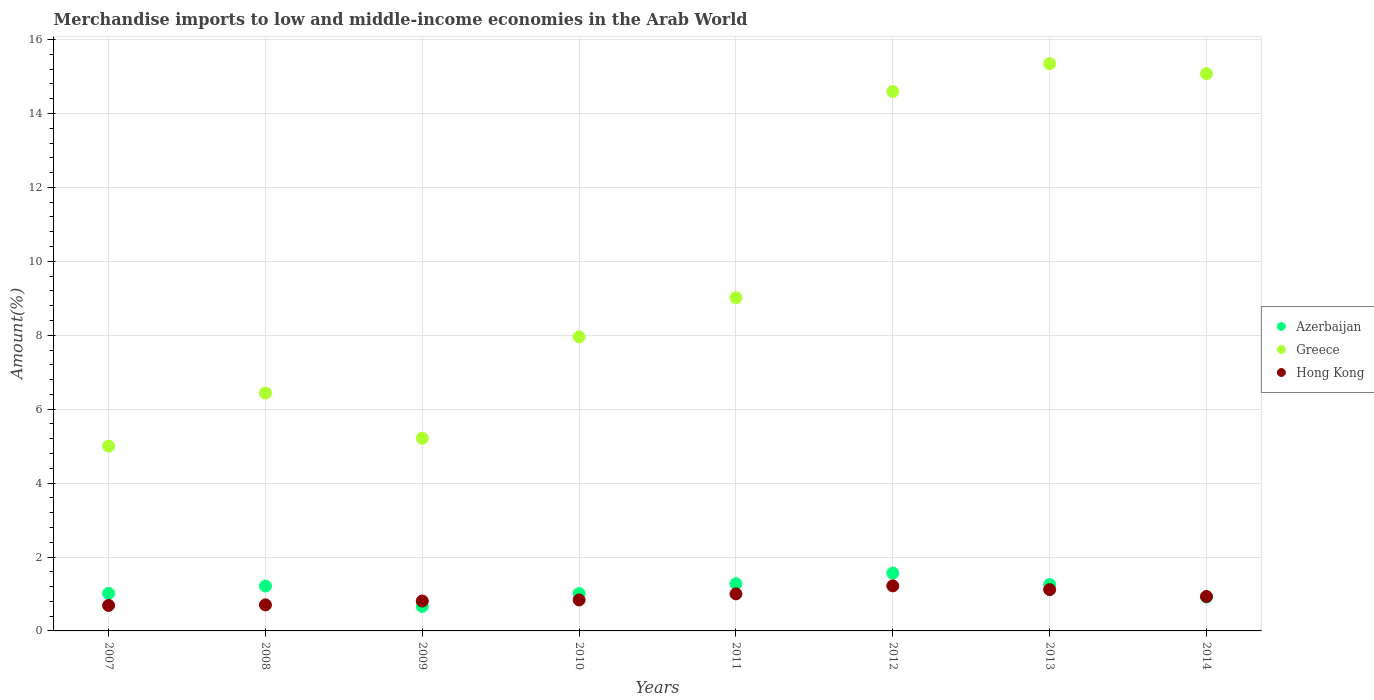How many different coloured dotlines are there?
Your answer should be very brief. 3. Is the number of dotlines equal to the number of legend labels?
Make the answer very short. Yes. What is the percentage of amount earned from merchandise imports in Hong Kong in 2009?
Your response must be concise. 0.81. Across all years, what is the maximum percentage of amount earned from merchandise imports in Greece?
Provide a succinct answer. 15.35. Across all years, what is the minimum percentage of amount earned from merchandise imports in Hong Kong?
Your response must be concise. 0.69. In which year was the percentage of amount earned from merchandise imports in Hong Kong maximum?
Offer a very short reply. 2012. In which year was the percentage of amount earned from merchandise imports in Greece minimum?
Your answer should be compact. 2007. What is the total percentage of amount earned from merchandise imports in Greece in the graph?
Keep it short and to the point. 78.64. What is the difference between the percentage of amount earned from merchandise imports in Greece in 2011 and that in 2013?
Provide a short and direct response. -6.33. What is the difference between the percentage of amount earned from merchandise imports in Hong Kong in 2011 and the percentage of amount earned from merchandise imports in Azerbaijan in 2014?
Give a very brief answer. 0.09. What is the average percentage of amount earned from merchandise imports in Azerbaijan per year?
Your response must be concise. 1.11. In the year 2008, what is the difference between the percentage of amount earned from merchandise imports in Greece and percentage of amount earned from merchandise imports in Azerbaijan?
Provide a short and direct response. 5.22. What is the ratio of the percentage of amount earned from merchandise imports in Hong Kong in 2007 to that in 2011?
Your answer should be very brief. 0.69. Is the difference between the percentage of amount earned from merchandise imports in Greece in 2009 and 2014 greater than the difference between the percentage of amount earned from merchandise imports in Azerbaijan in 2009 and 2014?
Your response must be concise. No. What is the difference between the highest and the second highest percentage of amount earned from merchandise imports in Greece?
Offer a very short reply. 0.27. What is the difference between the highest and the lowest percentage of amount earned from merchandise imports in Azerbaijan?
Your answer should be compact. 0.9. In how many years, is the percentage of amount earned from merchandise imports in Hong Kong greater than the average percentage of amount earned from merchandise imports in Hong Kong taken over all years?
Your answer should be very brief. 4. Is the sum of the percentage of amount earned from merchandise imports in Greece in 2010 and 2011 greater than the maximum percentage of amount earned from merchandise imports in Azerbaijan across all years?
Your response must be concise. Yes. Does the percentage of amount earned from merchandise imports in Hong Kong monotonically increase over the years?
Offer a terse response. No. How many dotlines are there?
Offer a terse response. 3. How many years are there in the graph?
Provide a short and direct response. 8. What is the difference between two consecutive major ticks on the Y-axis?
Provide a short and direct response. 2. Are the values on the major ticks of Y-axis written in scientific E-notation?
Offer a terse response. No. Does the graph contain grids?
Offer a very short reply. Yes. How many legend labels are there?
Offer a terse response. 3. How are the legend labels stacked?
Make the answer very short. Vertical. What is the title of the graph?
Ensure brevity in your answer.  Merchandise imports to low and middle-income economies in the Arab World. Does "Kuwait" appear as one of the legend labels in the graph?
Your answer should be very brief. No. What is the label or title of the Y-axis?
Your answer should be very brief. Amount(%). What is the Amount(%) in Azerbaijan in 2007?
Provide a short and direct response. 1.02. What is the Amount(%) in Greece in 2007?
Your answer should be compact. 5. What is the Amount(%) of Hong Kong in 2007?
Keep it short and to the point. 0.69. What is the Amount(%) of Azerbaijan in 2008?
Provide a succinct answer. 1.21. What is the Amount(%) in Greece in 2008?
Your response must be concise. 6.44. What is the Amount(%) of Hong Kong in 2008?
Ensure brevity in your answer.  0.7. What is the Amount(%) in Azerbaijan in 2009?
Make the answer very short. 0.66. What is the Amount(%) of Greece in 2009?
Your answer should be very brief. 5.21. What is the Amount(%) in Hong Kong in 2009?
Your response must be concise. 0.81. What is the Amount(%) in Azerbaijan in 2010?
Offer a terse response. 1.01. What is the Amount(%) in Greece in 2010?
Offer a very short reply. 7.96. What is the Amount(%) of Hong Kong in 2010?
Provide a succinct answer. 0.84. What is the Amount(%) in Azerbaijan in 2011?
Give a very brief answer. 1.28. What is the Amount(%) of Greece in 2011?
Offer a terse response. 9.02. What is the Amount(%) of Hong Kong in 2011?
Make the answer very short. 1. What is the Amount(%) of Azerbaijan in 2012?
Offer a terse response. 1.57. What is the Amount(%) of Greece in 2012?
Your answer should be compact. 14.59. What is the Amount(%) of Hong Kong in 2012?
Give a very brief answer. 1.22. What is the Amount(%) in Azerbaijan in 2013?
Ensure brevity in your answer.  1.25. What is the Amount(%) of Greece in 2013?
Provide a short and direct response. 15.35. What is the Amount(%) of Hong Kong in 2013?
Your response must be concise. 1.12. What is the Amount(%) in Azerbaijan in 2014?
Your answer should be compact. 0.91. What is the Amount(%) of Greece in 2014?
Keep it short and to the point. 15.08. What is the Amount(%) in Hong Kong in 2014?
Provide a short and direct response. 0.93. Across all years, what is the maximum Amount(%) in Azerbaijan?
Your answer should be very brief. 1.57. Across all years, what is the maximum Amount(%) in Greece?
Your answer should be compact. 15.35. Across all years, what is the maximum Amount(%) of Hong Kong?
Ensure brevity in your answer.  1.22. Across all years, what is the minimum Amount(%) in Azerbaijan?
Ensure brevity in your answer.  0.66. Across all years, what is the minimum Amount(%) in Greece?
Offer a terse response. 5. Across all years, what is the minimum Amount(%) of Hong Kong?
Ensure brevity in your answer.  0.69. What is the total Amount(%) of Azerbaijan in the graph?
Keep it short and to the point. 8.92. What is the total Amount(%) of Greece in the graph?
Make the answer very short. 78.64. What is the total Amount(%) in Hong Kong in the graph?
Give a very brief answer. 7.31. What is the difference between the Amount(%) of Azerbaijan in 2007 and that in 2008?
Your response must be concise. -0.2. What is the difference between the Amount(%) in Greece in 2007 and that in 2008?
Keep it short and to the point. -1.43. What is the difference between the Amount(%) in Hong Kong in 2007 and that in 2008?
Ensure brevity in your answer.  -0.01. What is the difference between the Amount(%) in Azerbaijan in 2007 and that in 2009?
Make the answer very short. 0.35. What is the difference between the Amount(%) of Greece in 2007 and that in 2009?
Your answer should be very brief. -0.21. What is the difference between the Amount(%) in Hong Kong in 2007 and that in 2009?
Keep it short and to the point. -0.12. What is the difference between the Amount(%) of Azerbaijan in 2007 and that in 2010?
Your answer should be very brief. 0. What is the difference between the Amount(%) of Greece in 2007 and that in 2010?
Provide a short and direct response. -2.95. What is the difference between the Amount(%) in Hong Kong in 2007 and that in 2010?
Provide a succinct answer. -0.15. What is the difference between the Amount(%) in Azerbaijan in 2007 and that in 2011?
Make the answer very short. -0.26. What is the difference between the Amount(%) of Greece in 2007 and that in 2011?
Your answer should be compact. -4.02. What is the difference between the Amount(%) in Hong Kong in 2007 and that in 2011?
Offer a terse response. -0.31. What is the difference between the Amount(%) in Azerbaijan in 2007 and that in 2012?
Your answer should be compact. -0.55. What is the difference between the Amount(%) in Greece in 2007 and that in 2012?
Your response must be concise. -9.59. What is the difference between the Amount(%) in Hong Kong in 2007 and that in 2012?
Provide a succinct answer. -0.53. What is the difference between the Amount(%) of Azerbaijan in 2007 and that in 2013?
Provide a short and direct response. -0.24. What is the difference between the Amount(%) of Greece in 2007 and that in 2013?
Provide a succinct answer. -10.35. What is the difference between the Amount(%) in Hong Kong in 2007 and that in 2013?
Offer a very short reply. -0.43. What is the difference between the Amount(%) of Azerbaijan in 2007 and that in 2014?
Offer a terse response. 0.1. What is the difference between the Amount(%) in Greece in 2007 and that in 2014?
Your answer should be very brief. -10.08. What is the difference between the Amount(%) of Hong Kong in 2007 and that in 2014?
Ensure brevity in your answer.  -0.24. What is the difference between the Amount(%) in Azerbaijan in 2008 and that in 2009?
Offer a very short reply. 0.55. What is the difference between the Amount(%) in Greece in 2008 and that in 2009?
Your answer should be compact. 1.22. What is the difference between the Amount(%) in Hong Kong in 2008 and that in 2009?
Make the answer very short. -0.1. What is the difference between the Amount(%) in Azerbaijan in 2008 and that in 2010?
Your answer should be very brief. 0.2. What is the difference between the Amount(%) of Greece in 2008 and that in 2010?
Your answer should be compact. -1.52. What is the difference between the Amount(%) in Hong Kong in 2008 and that in 2010?
Provide a short and direct response. -0.13. What is the difference between the Amount(%) in Azerbaijan in 2008 and that in 2011?
Your response must be concise. -0.06. What is the difference between the Amount(%) in Greece in 2008 and that in 2011?
Provide a short and direct response. -2.58. What is the difference between the Amount(%) in Hong Kong in 2008 and that in 2011?
Provide a short and direct response. -0.3. What is the difference between the Amount(%) of Azerbaijan in 2008 and that in 2012?
Your answer should be very brief. -0.35. What is the difference between the Amount(%) in Greece in 2008 and that in 2012?
Your answer should be compact. -8.16. What is the difference between the Amount(%) of Hong Kong in 2008 and that in 2012?
Provide a short and direct response. -0.52. What is the difference between the Amount(%) of Azerbaijan in 2008 and that in 2013?
Your answer should be very brief. -0.04. What is the difference between the Amount(%) of Greece in 2008 and that in 2013?
Your answer should be compact. -8.91. What is the difference between the Amount(%) in Hong Kong in 2008 and that in 2013?
Offer a very short reply. -0.41. What is the difference between the Amount(%) of Azerbaijan in 2008 and that in 2014?
Give a very brief answer. 0.3. What is the difference between the Amount(%) of Greece in 2008 and that in 2014?
Your response must be concise. -8.64. What is the difference between the Amount(%) of Hong Kong in 2008 and that in 2014?
Provide a succinct answer. -0.23. What is the difference between the Amount(%) in Azerbaijan in 2009 and that in 2010?
Make the answer very short. -0.35. What is the difference between the Amount(%) of Greece in 2009 and that in 2010?
Provide a short and direct response. -2.74. What is the difference between the Amount(%) of Hong Kong in 2009 and that in 2010?
Give a very brief answer. -0.03. What is the difference between the Amount(%) of Azerbaijan in 2009 and that in 2011?
Make the answer very short. -0.61. What is the difference between the Amount(%) in Greece in 2009 and that in 2011?
Provide a short and direct response. -3.8. What is the difference between the Amount(%) of Hong Kong in 2009 and that in 2011?
Your answer should be very brief. -0.19. What is the difference between the Amount(%) of Azerbaijan in 2009 and that in 2012?
Provide a short and direct response. -0.9. What is the difference between the Amount(%) of Greece in 2009 and that in 2012?
Make the answer very short. -9.38. What is the difference between the Amount(%) in Hong Kong in 2009 and that in 2012?
Keep it short and to the point. -0.41. What is the difference between the Amount(%) in Azerbaijan in 2009 and that in 2013?
Offer a very short reply. -0.59. What is the difference between the Amount(%) of Greece in 2009 and that in 2013?
Offer a terse response. -10.13. What is the difference between the Amount(%) of Hong Kong in 2009 and that in 2013?
Offer a terse response. -0.31. What is the difference between the Amount(%) in Azerbaijan in 2009 and that in 2014?
Offer a terse response. -0.25. What is the difference between the Amount(%) of Greece in 2009 and that in 2014?
Your response must be concise. -9.86. What is the difference between the Amount(%) of Hong Kong in 2009 and that in 2014?
Keep it short and to the point. -0.12. What is the difference between the Amount(%) of Azerbaijan in 2010 and that in 2011?
Your answer should be compact. -0.26. What is the difference between the Amount(%) of Greece in 2010 and that in 2011?
Make the answer very short. -1.06. What is the difference between the Amount(%) in Hong Kong in 2010 and that in 2011?
Keep it short and to the point. -0.17. What is the difference between the Amount(%) in Azerbaijan in 2010 and that in 2012?
Provide a short and direct response. -0.55. What is the difference between the Amount(%) in Greece in 2010 and that in 2012?
Your response must be concise. -6.64. What is the difference between the Amount(%) in Hong Kong in 2010 and that in 2012?
Keep it short and to the point. -0.38. What is the difference between the Amount(%) in Azerbaijan in 2010 and that in 2013?
Make the answer very short. -0.24. What is the difference between the Amount(%) in Greece in 2010 and that in 2013?
Ensure brevity in your answer.  -7.39. What is the difference between the Amount(%) of Hong Kong in 2010 and that in 2013?
Offer a very short reply. -0.28. What is the difference between the Amount(%) in Azerbaijan in 2010 and that in 2014?
Provide a short and direct response. 0.1. What is the difference between the Amount(%) of Greece in 2010 and that in 2014?
Make the answer very short. -7.12. What is the difference between the Amount(%) of Hong Kong in 2010 and that in 2014?
Ensure brevity in your answer.  -0.09. What is the difference between the Amount(%) in Azerbaijan in 2011 and that in 2012?
Offer a terse response. -0.29. What is the difference between the Amount(%) of Greece in 2011 and that in 2012?
Offer a terse response. -5.58. What is the difference between the Amount(%) of Hong Kong in 2011 and that in 2012?
Provide a short and direct response. -0.22. What is the difference between the Amount(%) of Azerbaijan in 2011 and that in 2013?
Make the answer very short. 0.02. What is the difference between the Amount(%) of Greece in 2011 and that in 2013?
Offer a terse response. -6.33. What is the difference between the Amount(%) of Hong Kong in 2011 and that in 2013?
Provide a succinct answer. -0.12. What is the difference between the Amount(%) of Azerbaijan in 2011 and that in 2014?
Your response must be concise. 0.36. What is the difference between the Amount(%) of Greece in 2011 and that in 2014?
Provide a short and direct response. -6.06. What is the difference between the Amount(%) in Hong Kong in 2011 and that in 2014?
Offer a terse response. 0.07. What is the difference between the Amount(%) of Azerbaijan in 2012 and that in 2013?
Keep it short and to the point. 0.31. What is the difference between the Amount(%) of Greece in 2012 and that in 2013?
Offer a very short reply. -0.75. What is the difference between the Amount(%) of Hong Kong in 2012 and that in 2013?
Give a very brief answer. 0.1. What is the difference between the Amount(%) in Azerbaijan in 2012 and that in 2014?
Make the answer very short. 0.65. What is the difference between the Amount(%) in Greece in 2012 and that in 2014?
Your answer should be very brief. -0.48. What is the difference between the Amount(%) in Hong Kong in 2012 and that in 2014?
Give a very brief answer. 0.29. What is the difference between the Amount(%) in Azerbaijan in 2013 and that in 2014?
Your response must be concise. 0.34. What is the difference between the Amount(%) in Greece in 2013 and that in 2014?
Offer a very short reply. 0.27. What is the difference between the Amount(%) in Hong Kong in 2013 and that in 2014?
Offer a terse response. 0.19. What is the difference between the Amount(%) of Azerbaijan in 2007 and the Amount(%) of Greece in 2008?
Offer a terse response. -5.42. What is the difference between the Amount(%) in Azerbaijan in 2007 and the Amount(%) in Hong Kong in 2008?
Keep it short and to the point. 0.31. What is the difference between the Amount(%) of Greece in 2007 and the Amount(%) of Hong Kong in 2008?
Offer a terse response. 4.3. What is the difference between the Amount(%) of Azerbaijan in 2007 and the Amount(%) of Greece in 2009?
Ensure brevity in your answer.  -4.2. What is the difference between the Amount(%) of Azerbaijan in 2007 and the Amount(%) of Hong Kong in 2009?
Provide a short and direct response. 0.21. What is the difference between the Amount(%) of Greece in 2007 and the Amount(%) of Hong Kong in 2009?
Make the answer very short. 4.19. What is the difference between the Amount(%) in Azerbaijan in 2007 and the Amount(%) in Greece in 2010?
Keep it short and to the point. -6.94. What is the difference between the Amount(%) in Azerbaijan in 2007 and the Amount(%) in Hong Kong in 2010?
Ensure brevity in your answer.  0.18. What is the difference between the Amount(%) in Greece in 2007 and the Amount(%) in Hong Kong in 2010?
Keep it short and to the point. 4.16. What is the difference between the Amount(%) in Azerbaijan in 2007 and the Amount(%) in Greece in 2011?
Provide a short and direct response. -8. What is the difference between the Amount(%) in Azerbaijan in 2007 and the Amount(%) in Hong Kong in 2011?
Provide a succinct answer. 0.01. What is the difference between the Amount(%) of Greece in 2007 and the Amount(%) of Hong Kong in 2011?
Ensure brevity in your answer.  4. What is the difference between the Amount(%) in Azerbaijan in 2007 and the Amount(%) in Greece in 2012?
Offer a very short reply. -13.58. What is the difference between the Amount(%) in Azerbaijan in 2007 and the Amount(%) in Hong Kong in 2012?
Offer a very short reply. -0.2. What is the difference between the Amount(%) in Greece in 2007 and the Amount(%) in Hong Kong in 2012?
Your answer should be very brief. 3.78. What is the difference between the Amount(%) of Azerbaijan in 2007 and the Amount(%) of Greece in 2013?
Offer a very short reply. -14.33. What is the difference between the Amount(%) in Azerbaijan in 2007 and the Amount(%) in Hong Kong in 2013?
Your response must be concise. -0.1. What is the difference between the Amount(%) in Greece in 2007 and the Amount(%) in Hong Kong in 2013?
Your answer should be compact. 3.88. What is the difference between the Amount(%) of Azerbaijan in 2007 and the Amount(%) of Greece in 2014?
Ensure brevity in your answer.  -14.06. What is the difference between the Amount(%) in Azerbaijan in 2007 and the Amount(%) in Hong Kong in 2014?
Give a very brief answer. 0.08. What is the difference between the Amount(%) in Greece in 2007 and the Amount(%) in Hong Kong in 2014?
Your answer should be compact. 4.07. What is the difference between the Amount(%) of Azerbaijan in 2008 and the Amount(%) of Greece in 2009?
Provide a short and direct response. -4. What is the difference between the Amount(%) in Azerbaijan in 2008 and the Amount(%) in Hong Kong in 2009?
Provide a short and direct response. 0.41. What is the difference between the Amount(%) of Greece in 2008 and the Amount(%) of Hong Kong in 2009?
Make the answer very short. 5.63. What is the difference between the Amount(%) of Azerbaijan in 2008 and the Amount(%) of Greece in 2010?
Provide a succinct answer. -6.74. What is the difference between the Amount(%) of Azerbaijan in 2008 and the Amount(%) of Hong Kong in 2010?
Provide a short and direct response. 0.38. What is the difference between the Amount(%) in Greece in 2008 and the Amount(%) in Hong Kong in 2010?
Offer a very short reply. 5.6. What is the difference between the Amount(%) in Azerbaijan in 2008 and the Amount(%) in Greece in 2011?
Give a very brief answer. -7.8. What is the difference between the Amount(%) of Azerbaijan in 2008 and the Amount(%) of Hong Kong in 2011?
Provide a succinct answer. 0.21. What is the difference between the Amount(%) in Greece in 2008 and the Amount(%) in Hong Kong in 2011?
Offer a terse response. 5.43. What is the difference between the Amount(%) of Azerbaijan in 2008 and the Amount(%) of Greece in 2012?
Your response must be concise. -13.38. What is the difference between the Amount(%) of Azerbaijan in 2008 and the Amount(%) of Hong Kong in 2012?
Make the answer very short. -0.01. What is the difference between the Amount(%) of Greece in 2008 and the Amount(%) of Hong Kong in 2012?
Make the answer very short. 5.22. What is the difference between the Amount(%) of Azerbaijan in 2008 and the Amount(%) of Greece in 2013?
Your response must be concise. -14.13. What is the difference between the Amount(%) in Azerbaijan in 2008 and the Amount(%) in Hong Kong in 2013?
Ensure brevity in your answer.  0.1. What is the difference between the Amount(%) in Greece in 2008 and the Amount(%) in Hong Kong in 2013?
Your response must be concise. 5.32. What is the difference between the Amount(%) of Azerbaijan in 2008 and the Amount(%) of Greece in 2014?
Give a very brief answer. -13.86. What is the difference between the Amount(%) in Azerbaijan in 2008 and the Amount(%) in Hong Kong in 2014?
Give a very brief answer. 0.28. What is the difference between the Amount(%) of Greece in 2008 and the Amount(%) of Hong Kong in 2014?
Ensure brevity in your answer.  5.5. What is the difference between the Amount(%) of Azerbaijan in 2009 and the Amount(%) of Greece in 2010?
Offer a terse response. -7.29. What is the difference between the Amount(%) of Azerbaijan in 2009 and the Amount(%) of Hong Kong in 2010?
Give a very brief answer. -0.17. What is the difference between the Amount(%) of Greece in 2009 and the Amount(%) of Hong Kong in 2010?
Offer a terse response. 4.38. What is the difference between the Amount(%) of Azerbaijan in 2009 and the Amount(%) of Greece in 2011?
Your answer should be compact. -8.35. What is the difference between the Amount(%) in Azerbaijan in 2009 and the Amount(%) in Hong Kong in 2011?
Provide a short and direct response. -0.34. What is the difference between the Amount(%) in Greece in 2009 and the Amount(%) in Hong Kong in 2011?
Provide a succinct answer. 4.21. What is the difference between the Amount(%) in Azerbaijan in 2009 and the Amount(%) in Greece in 2012?
Provide a short and direct response. -13.93. What is the difference between the Amount(%) of Azerbaijan in 2009 and the Amount(%) of Hong Kong in 2012?
Your answer should be very brief. -0.56. What is the difference between the Amount(%) in Greece in 2009 and the Amount(%) in Hong Kong in 2012?
Provide a short and direct response. 4. What is the difference between the Amount(%) in Azerbaijan in 2009 and the Amount(%) in Greece in 2013?
Your response must be concise. -14.68. What is the difference between the Amount(%) of Azerbaijan in 2009 and the Amount(%) of Hong Kong in 2013?
Your answer should be very brief. -0.46. What is the difference between the Amount(%) in Greece in 2009 and the Amount(%) in Hong Kong in 2013?
Provide a short and direct response. 4.1. What is the difference between the Amount(%) of Azerbaijan in 2009 and the Amount(%) of Greece in 2014?
Keep it short and to the point. -14.41. What is the difference between the Amount(%) in Azerbaijan in 2009 and the Amount(%) in Hong Kong in 2014?
Your answer should be compact. -0.27. What is the difference between the Amount(%) of Greece in 2009 and the Amount(%) of Hong Kong in 2014?
Offer a terse response. 4.28. What is the difference between the Amount(%) in Azerbaijan in 2010 and the Amount(%) in Greece in 2011?
Provide a succinct answer. -8.01. What is the difference between the Amount(%) in Azerbaijan in 2010 and the Amount(%) in Hong Kong in 2011?
Keep it short and to the point. 0.01. What is the difference between the Amount(%) of Greece in 2010 and the Amount(%) of Hong Kong in 2011?
Ensure brevity in your answer.  6.95. What is the difference between the Amount(%) in Azerbaijan in 2010 and the Amount(%) in Greece in 2012?
Your answer should be very brief. -13.58. What is the difference between the Amount(%) of Azerbaijan in 2010 and the Amount(%) of Hong Kong in 2012?
Provide a succinct answer. -0.21. What is the difference between the Amount(%) of Greece in 2010 and the Amount(%) of Hong Kong in 2012?
Ensure brevity in your answer.  6.74. What is the difference between the Amount(%) of Azerbaijan in 2010 and the Amount(%) of Greece in 2013?
Provide a succinct answer. -14.34. What is the difference between the Amount(%) in Azerbaijan in 2010 and the Amount(%) in Hong Kong in 2013?
Offer a terse response. -0.11. What is the difference between the Amount(%) of Greece in 2010 and the Amount(%) of Hong Kong in 2013?
Make the answer very short. 6.84. What is the difference between the Amount(%) in Azerbaijan in 2010 and the Amount(%) in Greece in 2014?
Provide a short and direct response. -14.06. What is the difference between the Amount(%) in Azerbaijan in 2010 and the Amount(%) in Hong Kong in 2014?
Keep it short and to the point. 0.08. What is the difference between the Amount(%) in Greece in 2010 and the Amount(%) in Hong Kong in 2014?
Offer a terse response. 7.02. What is the difference between the Amount(%) in Azerbaijan in 2011 and the Amount(%) in Greece in 2012?
Your answer should be very brief. -13.32. What is the difference between the Amount(%) in Azerbaijan in 2011 and the Amount(%) in Hong Kong in 2012?
Provide a succinct answer. 0.06. What is the difference between the Amount(%) in Greece in 2011 and the Amount(%) in Hong Kong in 2012?
Give a very brief answer. 7.8. What is the difference between the Amount(%) of Azerbaijan in 2011 and the Amount(%) of Greece in 2013?
Your answer should be very brief. -14.07. What is the difference between the Amount(%) in Azerbaijan in 2011 and the Amount(%) in Hong Kong in 2013?
Your answer should be compact. 0.16. What is the difference between the Amount(%) in Greece in 2011 and the Amount(%) in Hong Kong in 2013?
Provide a succinct answer. 7.9. What is the difference between the Amount(%) in Azerbaijan in 2011 and the Amount(%) in Greece in 2014?
Your response must be concise. -13.8. What is the difference between the Amount(%) in Azerbaijan in 2011 and the Amount(%) in Hong Kong in 2014?
Offer a very short reply. 0.34. What is the difference between the Amount(%) in Greece in 2011 and the Amount(%) in Hong Kong in 2014?
Give a very brief answer. 8.09. What is the difference between the Amount(%) in Azerbaijan in 2012 and the Amount(%) in Greece in 2013?
Give a very brief answer. -13.78. What is the difference between the Amount(%) of Azerbaijan in 2012 and the Amount(%) of Hong Kong in 2013?
Keep it short and to the point. 0.45. What is the difference between the Amount(%) of Greece in 2012 and the Amount(%) of Hong Kong in 2013?
Your response must be concise. 13.48. What is the difference between the Amount(%) of Azerbaijan in 2012 and the Amount(%) of Greece in 2014?
Provide a short and direct response. -13.51. What is the difference between the Amount(%) of Azerbaijan in 2012 and the Amount(%) of Hong Kong in 2014?
Your answer should be compact. 0.63. What is the difference between the Amount(%) in Greece in 2012 and the Amount(%) in Hong Kong in 2014?
Make the answer very short. 13.66. What is the difference between the Amount(%) in Azerbaijan in 2013 and the Amount(%) in Greece in 2014?
Offer a very short reply. -13.82. What is the difference between the Amount(%) in Azerbaijan in 2013 and the Amount(%) in Hong Kong in 2014?
Make the answer very short. 0.32. What is the difference between the Amount(%) of Greece in 2013 and the Amount(%) of Hong Kong in 2014?
Keep it short and to the point. 14.41. What is the average Amount(%) in Azerbaijan per year?
Keep it short and to the point. 1.11. What is the average Amount(%) of Greece per year?
Keep it short and to the point. 9.83. What is the average Amount(%) in Hong Kong per year?
Provide a succinct answer. 0.91. In the year 2007, what is the difference between the Amount(%) of Azerbaijan and Amount(%) of Greece?
Give a very brief answer. -3.98. In the year 2007, what is the difference between the Amount(%) in Azerbaijan and Amount(%) in Hong Kong?
Offer a terse response. 0.33. In the year 2007, what is the difference between the Amount(%) of Greece and Amount(%) of Hong Kong?
Provide a succinct answer. 4.31. In the year 2008, what is the difference between the Amount(%) in Azerbaijan and Amount(%) in Greece?
Make the answer very short. -5.22. In the year 2008, what is the difference between the Amount(%) of Azerbaijan and Amount(%) of Hong Kong?
Your answer should be compact. 0.51. In the year 2008, what is the difference between the Amount(%) in Greece and Amount(%) in Hong Kong?
Provide a succinct answer. 5.73. In the year 2009, what is the difference between the Amount(%) of Azerbaijan and Amount(%) of Greece?
Ensure brevity in your answer.  -4.55. In the year 2009, what is the difference between the Amount(%) in Azerbaijan and Amount(%) in Hong Kong?
Offer a terse response. -0.15. In the year 2009, what is the difference between the Amount(%) of Greece and Amount(%) of Hong Kong?
Your answer should be very brief. 4.41. In the year 2010, what is the difference between the Amount(%) of Azerbaijan and Amount(%) of Greece?
Make the answer very short. -6.94. In the year 2010, what is the difference between the Amount(%) in Azerbaijan and Amount(%) in Hong Kong?
Give a very brief answer. 0.17. In the year 2010, what is the difference between the Amount(%) in Greece and Amount(%) in Hong Kong?
Your response must be concise. 7.12. In the year 2011, what is the difference between the Amount(%) in Azerbaijan and Amount(%) in Greece?
Your answer should be compact. -7.74. In the year 2011, what is the difference between the Amount(%) in Azerbaijan and Amount(%) in Hong Kong?
Your answer should be very brief. 0.27. In the year 2011, what is the difference between the Amount(%) in Greece and Amount(%) in Hong Kong?
Make the answer very short. 8.01. In the year 2012, what is the difference between the Amount(%) of Azerbaijan and Amount(%) of Greece?
Provide a short and direct response. -13.03. In the year 2012, what is the difference between the Amount(%) of Azerbaijan and Amount(%) of Hong Kong?
Your answer should be compact. 0.35. In the year 2012, what is the difference between the Amount(%) of Greece and Amount(%) of Hong Kong?
Offer a very short reply. 13.37. In the year 2013, what is the difference between the Amount(%) of Azerbaijan and Amount(%) of Greece?
Ensure brevity in your answer.  -14.09. In the year 2013, what is the difference between the Amount(%) in Azerbaijan and Amount(%) in Hong Kong?
Provide a short and direct response. 0.14. In the year 2013, what is the difference between the Amount(%) in Greece and Amount(%) in Hong Kong?
Your response must be concise. 14.23. In the year 2014, what is the difference between the Amount(%) in Azerbaijan and Amount(%) in Greece?
Make the answer very short. -14.16. In the year 2014, what is the difference between the Amount(%) in Azerbaijan and Amount(%) in Hong Kong?
Provide a short and direct response. -0.02. In the year 2014, what is the difference between the Amount(%) of Greece and Amount(%) of Hong Kong?
Make the answer very short. 14.14. What is the ratio of the Amount(%) in Azerbaijan in 2007 to that in 2008?
Your answer should be very brief. 0.84. What is the ratio of the Amount(%) in Greece in 2007 to that in 2008?
Keep it short and to the point. 0.78. What is the ratio of the Amount(%) in Hong Kong in 2007 to that in 2008?
Provide a succinct answer. 0.98. What is the ratio of the Amount(%) of Azerbaijan in 2007 to that in 2009?
Ensure brevity in your answer.  1.53. What is the ratio of the Amount(%) in Greece in 2007 to that in 2009?
Your answer should be very brief. 0.96. What is the ratio of the Amount(%) of Hong Kong in 2007 to that in 2009?
Offer a terse response. 0.85. What is the ratio of the Amount(%) in Greece in 2007 to that in 2010?
Keep it short and to the point. 0.63. What is the ratio of the Amount(%) of Hong Kong in 2007 to that in 2010?
Give a very brief answer. 0.82. What is the ratio of the Amount(%) of Azerbaijan in 2007 to that in 2011?
Ensure brevity in your answer.  0.8. What is the ratio of the Amount(%) in Greece in 2007 to that in 2011?
Keep it short and to the point. 0.55. What is the ratio of the Amount(%) of Hong Kong in 2007 to that in 2011?
Ensure brevity in your answer.  0.69. What is the ratio of the Amount(%) of Azerbaijan in 2007 to that in 2012?
Make the answer very short. 0.65. What is the ratio of the Amount(%) of Greece in 2007 to that in 2012?
Offer a very short reply. 0.34. What is the ratio of the Amount(%) in Hong Kong in 2007 to that in 2012?
Keep it short and to the point. 0.57. What is the ratio of the Amount(%) of Azerbaijan in 2007 to that in 2013?
Give a very brief answer. 0.81. What is the ratio of the Amount(%) of Greece in 2007 to that in 2013?
Offer a terse response. 0.33. What is the ratio of the Amount(%) in Hong Kong in 2007 to that in 2013?
Your response must be concise. 0.62. What is the ratio of the Amount(%) in Azerbaijan in 2007 to that in 2014?
Give a very brief answer. 1.11. What is the ratio of the Amount(%) of Greece in 2007 to that in 2014?
Provide a succinct answer. 0.33. What is the ratio of the Amount(%) in Hong Kong in 2007 to that in 2014?
Make the answer very short. 0.74. What is the ratio of the Amount(%) of Azerbaijan in 2008 to that in 2009?
Keep it short and to the point. 1.83. What is the ratio of the Amount(%) of Greece in 2008 to that in 2009?
Your answer should be compact. 1.23. What is the ratio of the Amount(%) in Hong Kong in 2008 to that in 2009?
Offer a terse response. 0.87. What is the ratio of the Amount(%) of Azerbaijan in 2008 to that in 2010?
Your answer should be compact. 1.2. What is the ratio of the Amount(%) in Greece in 2008 to that in 2010?
Keep it short and to the point. 0.81. What is the ratio of the Amount(%) of Hong Kong in 2008 to that in 2010?
Ensure brevity in your answer.  0.84. What is the ratio of the Amount(%) in Azerbaijan in 2008 to that in 2011?
Give a very brief answer. 0.95. What is the ratio of the Amount(%) of Greece in 2008 to that in 2011?
Provide a succinct answer. 0.71. What is the ratio of the Amount(%) of Hong Kong in 2008 to that in 2011?
Make the answer very short. 0.7. What is the ratio of the Amount(%) of Azerbaijan in 2008 to that in 2012?
Make the answer very short. 0.78. What is the ratio of the Amount(%) of Greece in 2008 to that in 2012?
Provide a succinct answer. 0.44. What is the ratio of the Amount(%) of Hong Kong in 2008 to that in 2012?
Your answer should be compact. 0.58. What is the ratio of the Amount(%) in Azerbaijan in 2008 to that in 2013?
Your answer should be very brief. 0.97. What is the ratio of the Amount(%) in Greece in 2008 to that in 2013?
Provide a succinct answer. 0.42. What is the ratio of the Amount(%) of Hong Kong in 2008 to that in 2013?
Your answer should be compact. 0.63. What is the ratio of the Amount(%) of Azerbaijan in 2008 to that in 2014?
Your answer should be compact. 1.33. What is the ratio of the Amount(%) of Greece in 2008 to that in 2014?
Keep it short and to the point. 0.43. What is the ratio of the Amount(%) of Hong Kong in 2008 to that in 2014?
Your answer should be very brief. 0.76. What is the ratio of the Amount(%) of Azerbaijan in 2009 to that in 2010?
Keep it short and to the point. 0.66. What is the ratio of the Amount(%) in Greece in 2009 to that in 2010?
Your answer should be very brief. 0.66. What is the ratio of the Amount(%) of Hong Kong in 2009 to that in 2010?
Keep it short and to the point. 0.97. What is the ratio of the Amount(%) of Azerbaijan in 2009 to that in 2011?
Keep it short and to the point. 0.52. What is the ratio of the Amount(%) in Greece in 2009 to that in 2011?
Your answer should be very brief. 0.58. What is the ratio of the Amount(%) in Hong Kong in 2009 to that in 2011?
Your response must be concise. 0.81. What is the ratio of the Amount(%) in Azerbaijan in 2009 to that in 2012?
Give a very brief answer. 0.42. What is the ratio of the Amount(%) in Greece in 2009 to that in 2012?
Provide a short and direct response. 0.36. What is the ratio of the Amount(%) of Hong Kong in 2009 to that in 2012?
Provide a short and direct response. 0.66. What is the ratio of the Amount(%) of Azerbaijan in 2009 to that in 2013?
Ensure brevity in your answer.  0.53. What is the ratio of the Amount(%) in Greece in 2009 to that in 2013?
Provide a short and direct response. 0.34. What is the ratio of the Amount(%) in Hong Kong in 2009 to that in 2013?
Offer a terse response. 0.72. What is the ratio of the Amount(%) in Azerbaijan in 2009 to that in 2014?
Your response must be concise. 0.72. What is the ratio of the Amount(%) in Greece in 2009 to that in 2014?
Keep it short and to the point. 0.35. What is the ratio of the Amount(%) in Hong Kong in 2009 to that in 2014?
Your answer should be very brief. 0.87. What is the ratio of the Amount(%) in Azerbaijan in 2010 to that in 2011?
Your answer should be very brief. 0.79. What is the ratio of the Amount(%) in Greece in 2010 to that in 2011?
Provide a short and direct response. 0.88. What is the ratio of the Amount(%) of Hong Kong in 2010 to that in 2011?
Provide a short and direct response. 0.84. What is the ratio of the Amount(%) in Azerbaijan in 2010 to that in 2012?
Give a very brief answer. 0.65. What is the ratio of the Amount(%) in Greece in 2010 to that in 2012?
Provide a short and direct response. 0.55. What is the ratio of the Amount(%) in Hong Kong in 2010 to that in 2012?
Make the answer very short. 0.69. What is the ratio of the Amount(%) in Azerbaijan in 2010 to that in 2013?
Your answer should be very brief. 0.81. What is the ratio of the Amount(%) of Greece in 2010 to that in 2013?
Provide a succinct answer. 0.52. What is the ratio of the Amount(%) of Hong Kong in 2010 to that in 2013?
Your answer should be compact. 0.75. What is the ratio of the Amount(%) of Azerbaijan in 2010 to that in 2014?
Ensure brevity in your answer.  1.11. What is the ratio of the Amount(%) of Greece in 2010 to that in 2014?
Make the answer very short. 0.53. What is the ratio of the Amount(%) of Hong Kong in 2010 to that in 2014?
Offer a very short reply. 0.9. What is the ratio of the Amount(%) of Azerbaijan in 2011 to that in 2012?
Your answer should be very brief. 0.82. What is the ratio of the Amount(%) in Greece in 2011 to that in 2012?
Offer a terse response. 0.62. What is the ratio of the Amount(%) of Hong Kong in 2011 to that in 2012?
Your response must be concise. 0.82. What is the ratio of the Amount(%) of Azerbaijan in 2011 to that in 2013?
Offer a terse response. 1.02. What is the ratio of the Amount(%) in Greece in 2011 to that in 2013?
Offer a terse response. 0.59. What is the ratio of the Amount(%) in Hong Kong in 2011 to that in 2013?
Make the answer very short. 0.9. What is the ratio of the Amount(%) in Azerbaijan in 2011 to that in 2014?
Make the answer very short. 1.4. What is the ratio of the Amount(%) in Greece in 2011 to that in 2014?
Ensure brevity in your answer.  0.6. What is the ratio of the Amount(%) in Hong Kong in 2011 to that in 2014?
Make the answer very short. 1.08. What is the ratio of the Amount(%) in Azerbaijan in 2012 to that in 2013?
Your response must be concise. 1.25. What is the ratio of the Amount(%) in Greece in 2012 to that in 2013?
Your answer should be very brief. 0.95. What is the ratio of the Amount(%) of Hong Kong in 2012 to that in 2013?
Offer a very short reply. 1.09. What is the ratio of the Amount(%) in Azerbaijan in 2012 to that in 2014?
Make the answer very short. 1.71. What is the ratio of the Amount(%) in Greece in 2012 to that in 2014?
Your answer should be very brief. 0.97. What is the ratio of the Amount(%) of Hong Kong in 2012 to that in 2014?
Keep it short and to the point. 1.31. What is the ratio of the Amount(%) in Azerbaijan in 2013 to that in 2014?
Your answer should be very brief. 1.37. What is the ratio of the Amount(%) of Greece in 2013 to that in 2014?
Provide a short and direct response. 1.02. What is the ratio of the Amount(%) in Hong Kong in 2013 to that in 2014?
Give a very brief answer. 1.2. What is the difference between the highest and the second highest Amount(%) of Azerbaijan?
Offer a terse response. 0.29. What is the difference between the highest and the second highest Amount(%) of Greece?
Provide a succinct answer. 0.27. What is the difference between the highest and the second highest Amount(%) in Hong Kong?
Your answer should be very brief. 0.1. What is the difference between the highest and the lowest Amount(%) in Azerbaijan?
Keep it short and to the point. 0.9. What is the difference between the highest and the lowest Amount(%) in Greece?
Keep it short and to the point. 10.35. What is the difference between the highest and the lowest Amount(%) in Hong Kong?
Give a very brief answer. 0.53. 